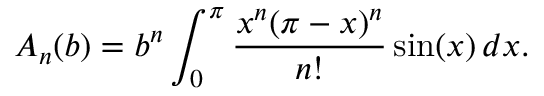<formula> <loc_0><loc_0><loc_500><loc_500>A _ { n } ( b ) = b ^ { n } \int _ { 0 } ^ { \pi } { \frac { x ^ { n } ( \pi - x ) ^ { n } } { n ! } } \sin ( x ) \, d x .</formula> 